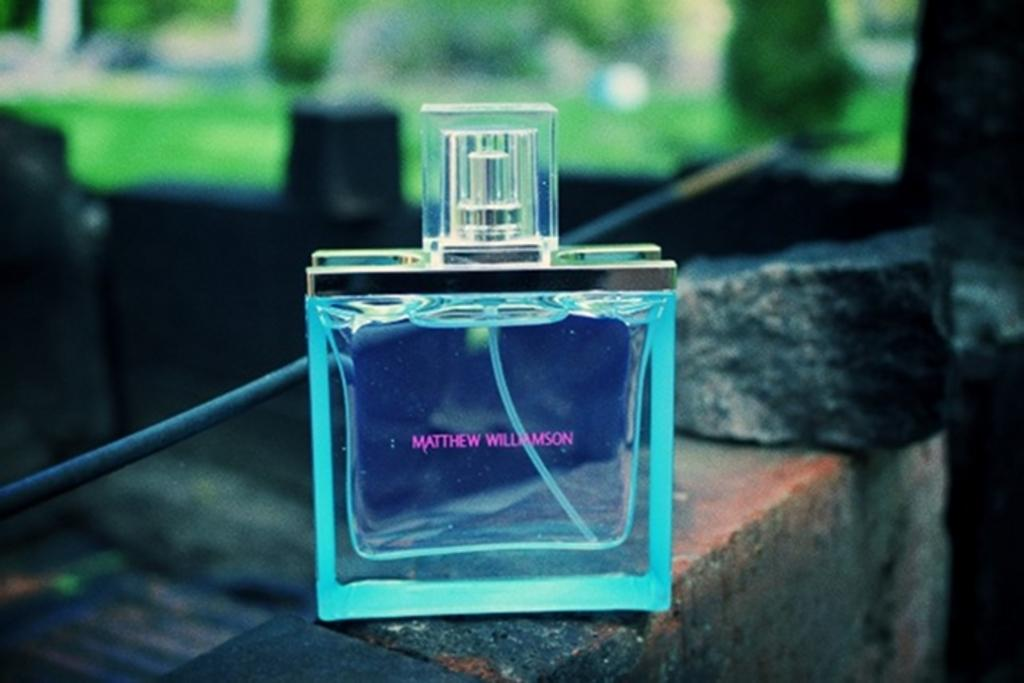Provide a one-sentence caption for the provided image. Bottle of Matthew Williamson perfume that is sitting on bricks. 